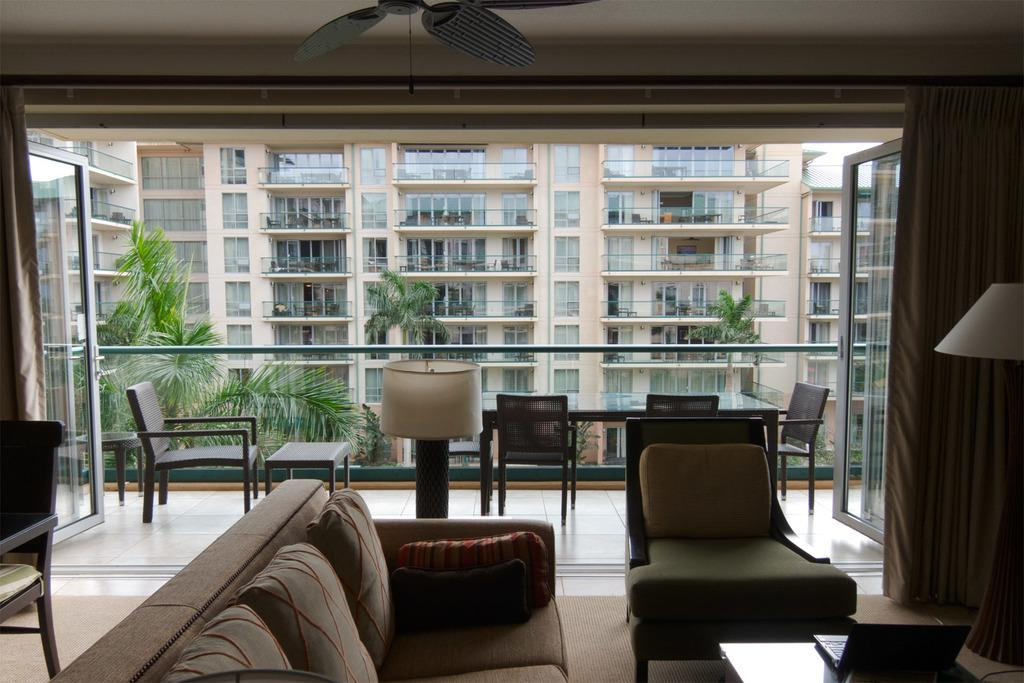What type of furniture is present in the image? There is a sofa and a chair in the image. What is the purpose of the lamp in the image? The lamp on the floor in the image is likely for providing light. What other piece of furniture can be seen in the image? There is a table in the image. What can be seen in the background of the image? There is a building and trees in the background of the image. What type of texture can be seen on the coach in the image? There is no coach present in the image; it features a sofa and a chair. 